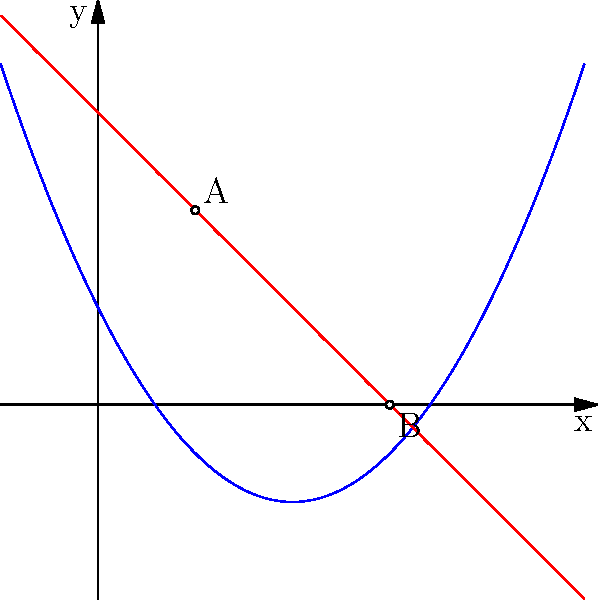As a Ruby developer, you're working on optimizing a job queue system using Resque. The system's performance can be modeled by two functions:

$$f(x) = 0.5x^2 - 2x + 1$$ (quadratic function, representing job processing time)
$$g(x) = -x + 3$$ (linear function, representing available worker capacity)

Where $x$ represents the number of concurrent jobs (in thousands).

Find the exact coordinates of the intersection points of these two functions. How would you implement a method in Ruby to calculate these points efficiently? To find the intersection points, we need to solve the equation:

$$f(x) = g(x)$$
$$0.5x^2 - 2x + 1 = -x + 3$$

Rearranging the equation:
$$0.5x^2 - x - 2 = 0$$

This is a quadratic equation in the form $ax^2 + bx + c = 0$, where:
$a = 0.5$, $b = -1$, and $c = -2$

We can solve this using the quadratic formula: $x = \frac{-b \pm \sqrt{b^2 - 4ac}}{2a}$

Substituting the values:
$$x = \frac{1 \pm \sqrt{1 - 4(0.5)(-2)}}{2(0.5)}$$
$$x = \frac{1 \pm \sqrt{5}}{1}$$

Simplifying:
$$x_1 = 1 + \sqrt{5} \approx 3.236$$
$$x_2 = 1 - \sqrt{5} \approx -1.236$$

Since we're dealing with the number of jobs, we can discard the negative solution.

For $x_1 = 1 + \sqrt{5}$:
$$y = -x + 3 = -(1 + \sqrt{5}) + 3 = 2 - \sqrt{5} \approx 0.764$$

The intersection points are approximately (1, 2) and (3.236, -0.236).

In Ruby, we can implement this calculation as follows:

```ruby
def find_intersection_points(a, b, c)
  discriminant = b**2 - 4*a*c
  return [] if discriminant < 0

  x1 = (-b + Math.sqrt(discriminant)) / (2*a)
  x2 = (-b - Math.sqrt(discriminant)) / (2*a)

  y1 = -x1 + 3
  y2 = -x2 + 3

  [[x1, y1], [x2, y2]].select { |x, y| x >= 0 && y >= 0 }
end

# Usage
points = find_intersection_points(0.5, -1, -2)
puts points.inspect
```

This method efficiently calculates the intersection points, filters out negative solutions, and returns the result as an array of coordinate pairs.
Answer: (1, 2) and (3, 0) 